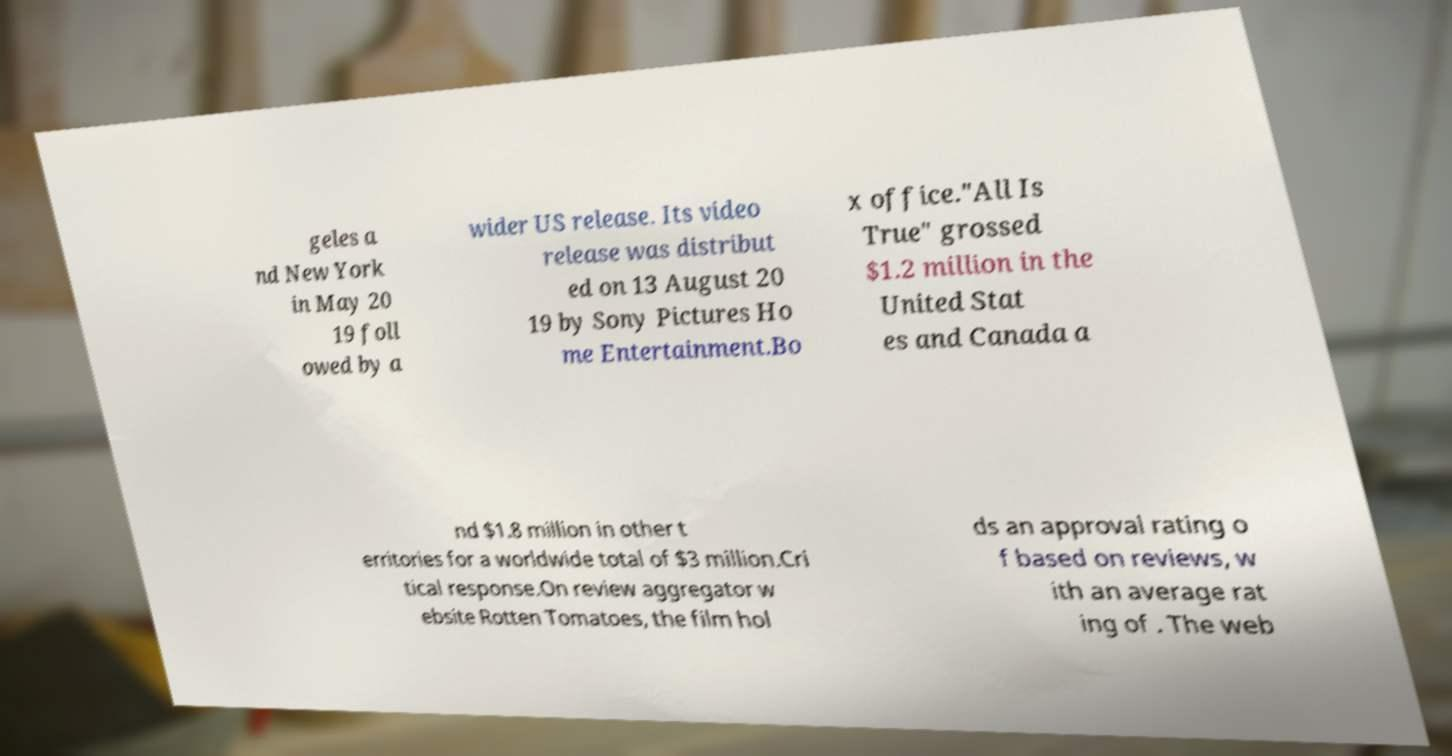I need the written content from this picture converted into text. Can you do that? geles a nd New York in May 20 19 foll owed by a wider US release. Its video release was distribut ed on 13 August 20 19 by Sony Pictures Ho me Entertainment.Bo x office."All Is True" grossed $1.2 million in the United Stat es and Canada a nd $1.8 million in other t erritories for a worldwide total of $3 million.Cri tical response.On review aggregator w ebsite Rotten Tomatoes, the film hol ds an approval rating o f based on reviews, w ith an average rat ing of . The web 